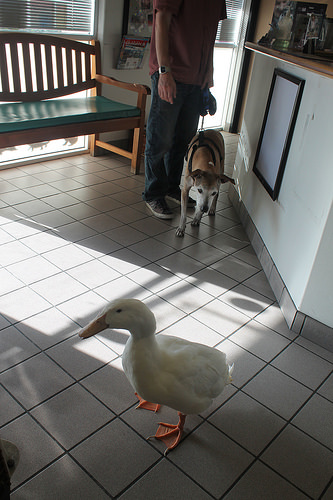<image>
Can you confirm if the dog is on the man? No. The dog is not positioned on the man. They may be near each other, but the dog is not supported by or resting on top of the man. 